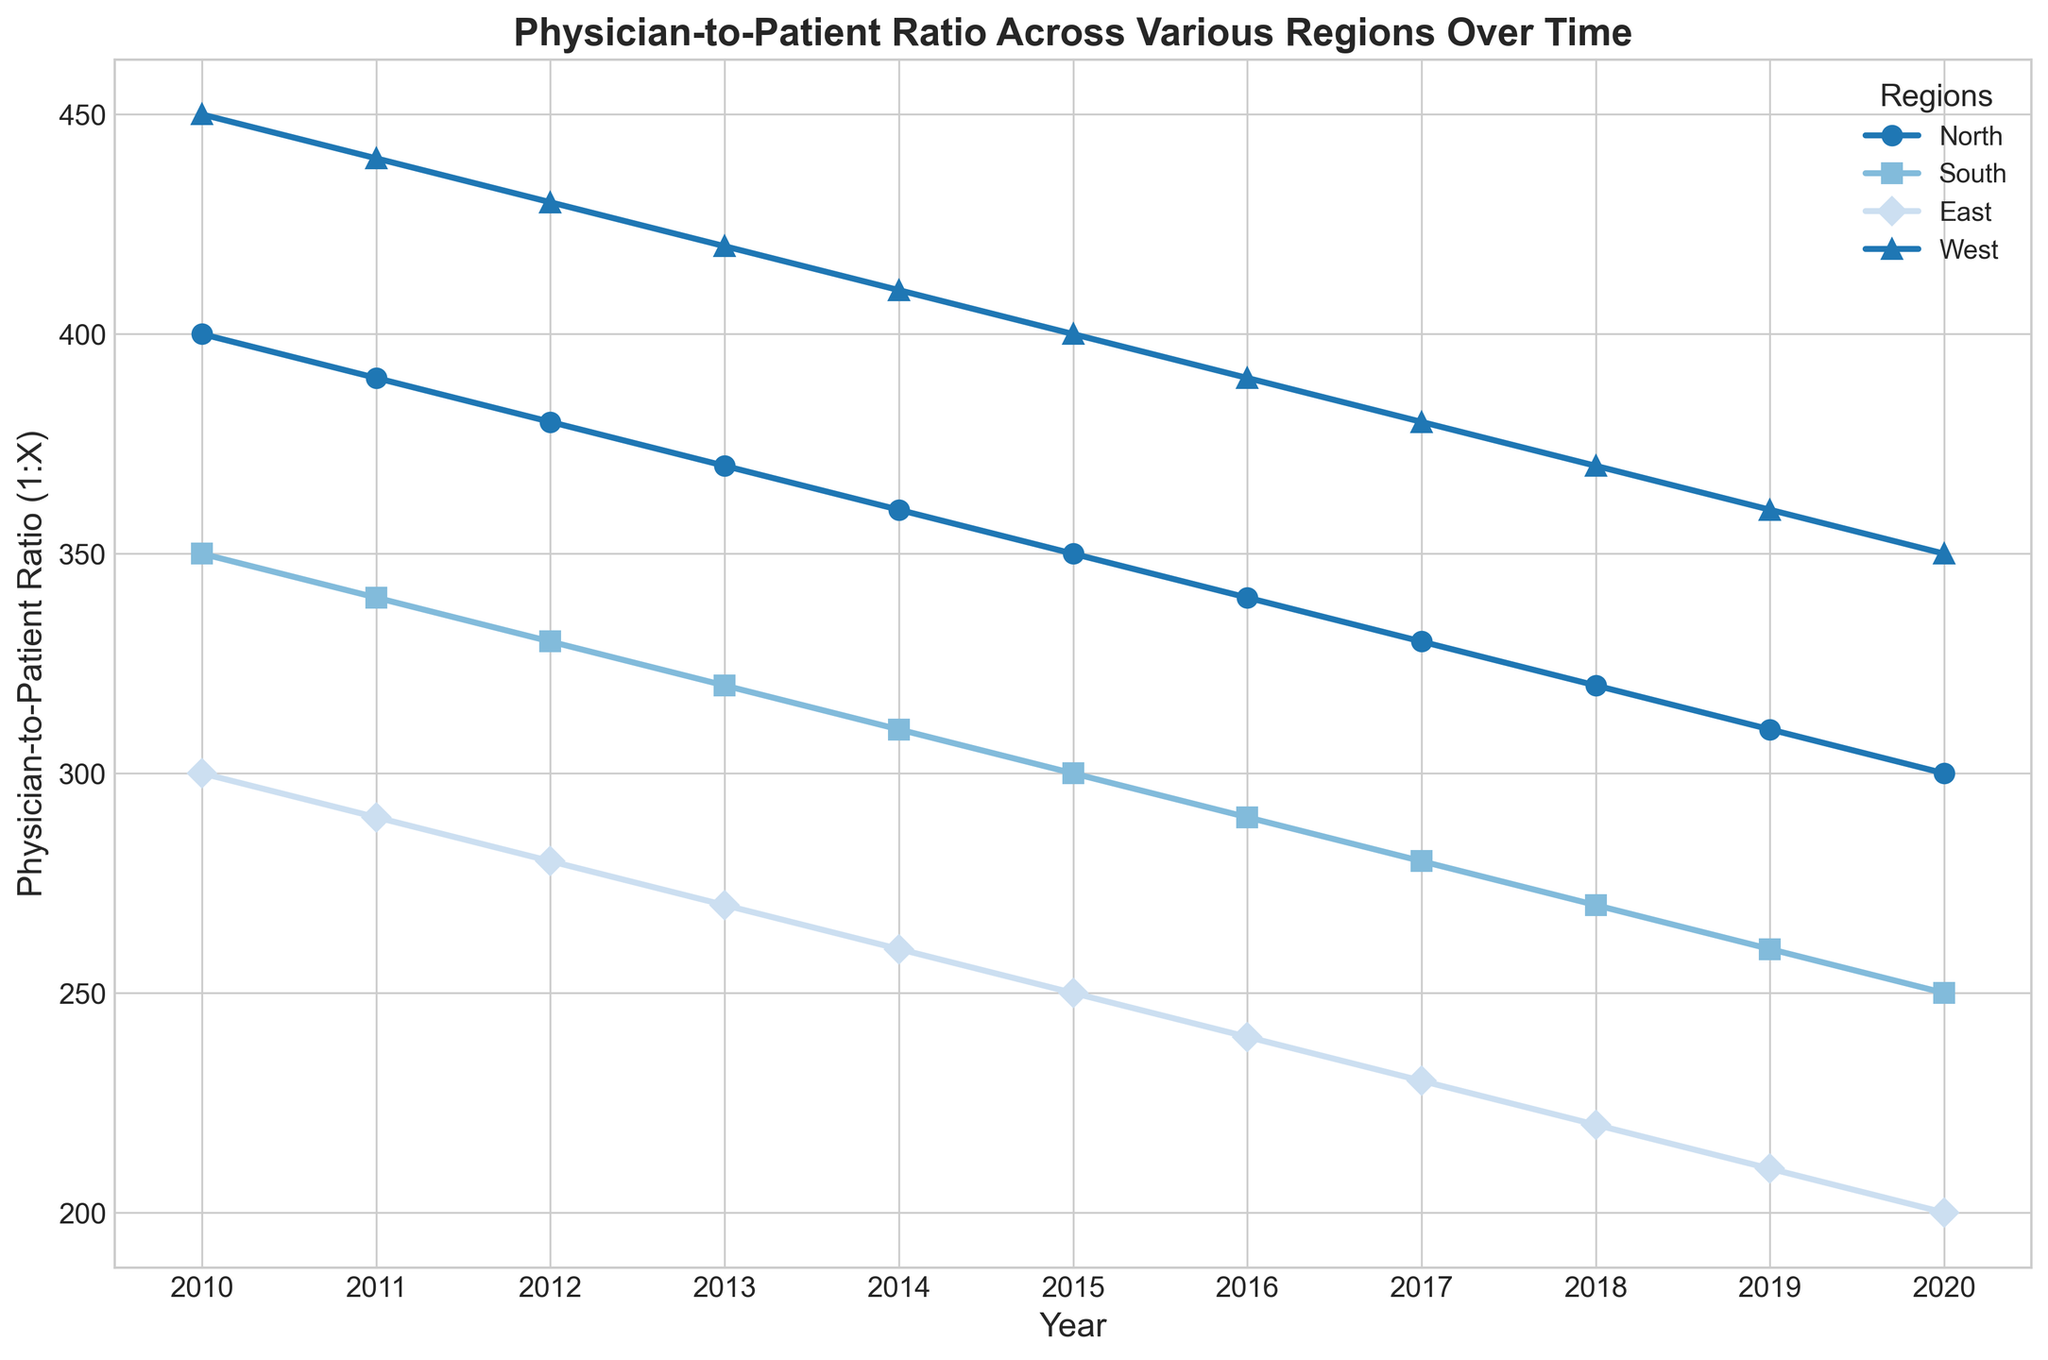What trend can you observe in the Physician-to-Patient Ratio for the North region from 2010 to 2020? Over time, the Physician-to-Patient Ratio in the North region consistently decreases from 1:400 in 2010 to 1:300 in 2020, indicating an improvement in physician availability.
Answer: Consistent decrease Which region had the lowest Physician-to-Patient Ratio in 2020, and what was the ratio? In 2020, the East region had the lowest Physician-to-Patient Ratio at 1:200. This can be determined by observing the end points of each line on the plot and identifying the lowest value.
Answer: East, 1:200 Compare the rate of improvement in Physician-to-Patient Ratio between the East and the West regions from 2010 to 2020. The East region's ratio improved from 1:300 to 1:200, a difference of 100 (300 - 200). The West region's ratio improved from 1:450 to 1:350, a difference of 100 (450 - 350). Therefore, both regions have the same rate of improvement over this period.
Answer: Same rate By how much did the Physician-to-Patient Ratio in the South region change from 2010 to 2015? In 2010, the ratio in the South was 1:350, and in 2015 it was 1:300. The change is 350 - 300 = 50. This indicates the ratio improved by 50 patients per physician.
Answer: Improved by 50 Which year shows the greatest improvement in Physician-to-Patient Ratio for the North region, and what is the improvement? The year with the greatest improvement for the North region is 2011, where the change was from 1:400 in 2010 to 1:390 in 2011, an improvement of 10. By comparing the differences each year, we see that the largest annual decrement is always 10 for the North region.
Answer: 2011, 10 Does any region have the same Physician-to-Patient Ratio in any two consecutive years? No region has the same Physician-to-Patient Ratio in any two consecutive years. This can be seen by inspecting the plot lines for any flat segments, none of which exist.
Answer: No By what percentage did the Physician-to-Patient Ratio improve in the West region from 2010 to 2020? In 2010, the ratio in the West was 1:450, and in 2020 it was 1:350. The improvement is 450 - 350 = 100. The percentage improvement is (100 / 450) * 100 = 22.22%.
Answer: 22.22% What is the average Physician-to-Patient Ratio for the South region over the decade? To find the average: (350 + 340 + 330 + 320 + 310 + 300 + 290 + 280 + 270 + 260 + 250) / 11 = 302.73. Sum up all the ratios from 2010 to 2020 and divide by the number of years (11).
Answer: 302.73 